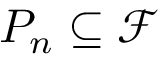<formula> <loc_0><loc_0><loc_500><loc_500>P _ { n } \subseteq \mathcal { F }</formula> 